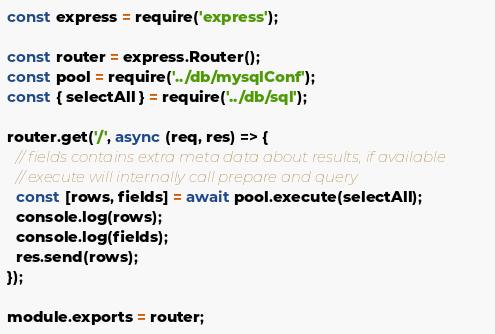<code> <loc_0><loc_0><loc_500><loc_500><_JavaScript_>const express = require('express');

const router = express.Router();
const pool = require('../db/mysqlConf');
const { selectAll } = require('../db/sql');

router.get('/', async (req, res) => {
  // fields contains extra meta data about results, if available
  // execute will internally call prepare and query
  const [rows, fields] = await pool.execute(selectAll);
  console.log(rows);
  console.log(fields);
  res.send(rows);
});

module.exports = router;
</code> 